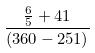Convert formula to latex. <formula><loc_0><loc_0><loc_500><loc_500>\frac { \frac { 6 } { 5 } + 4 1 } { ( 3 6 0 - 2 5 1 ) }</formula> 